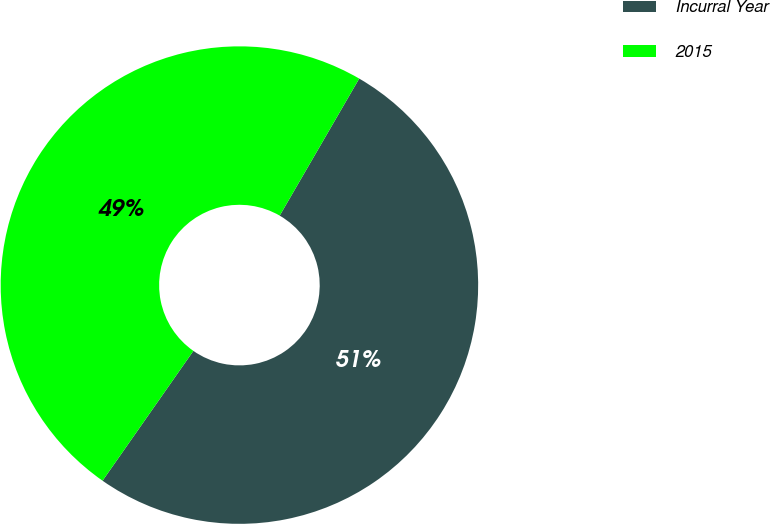Convert chart to OTSL. <chart><loc_0><loc_0><loc_500><loc_500><pie_chart><fcel>Incurral Year<fcel>2015<nl><fcel>51.35%<fcel>48.65%<nl></chart> 